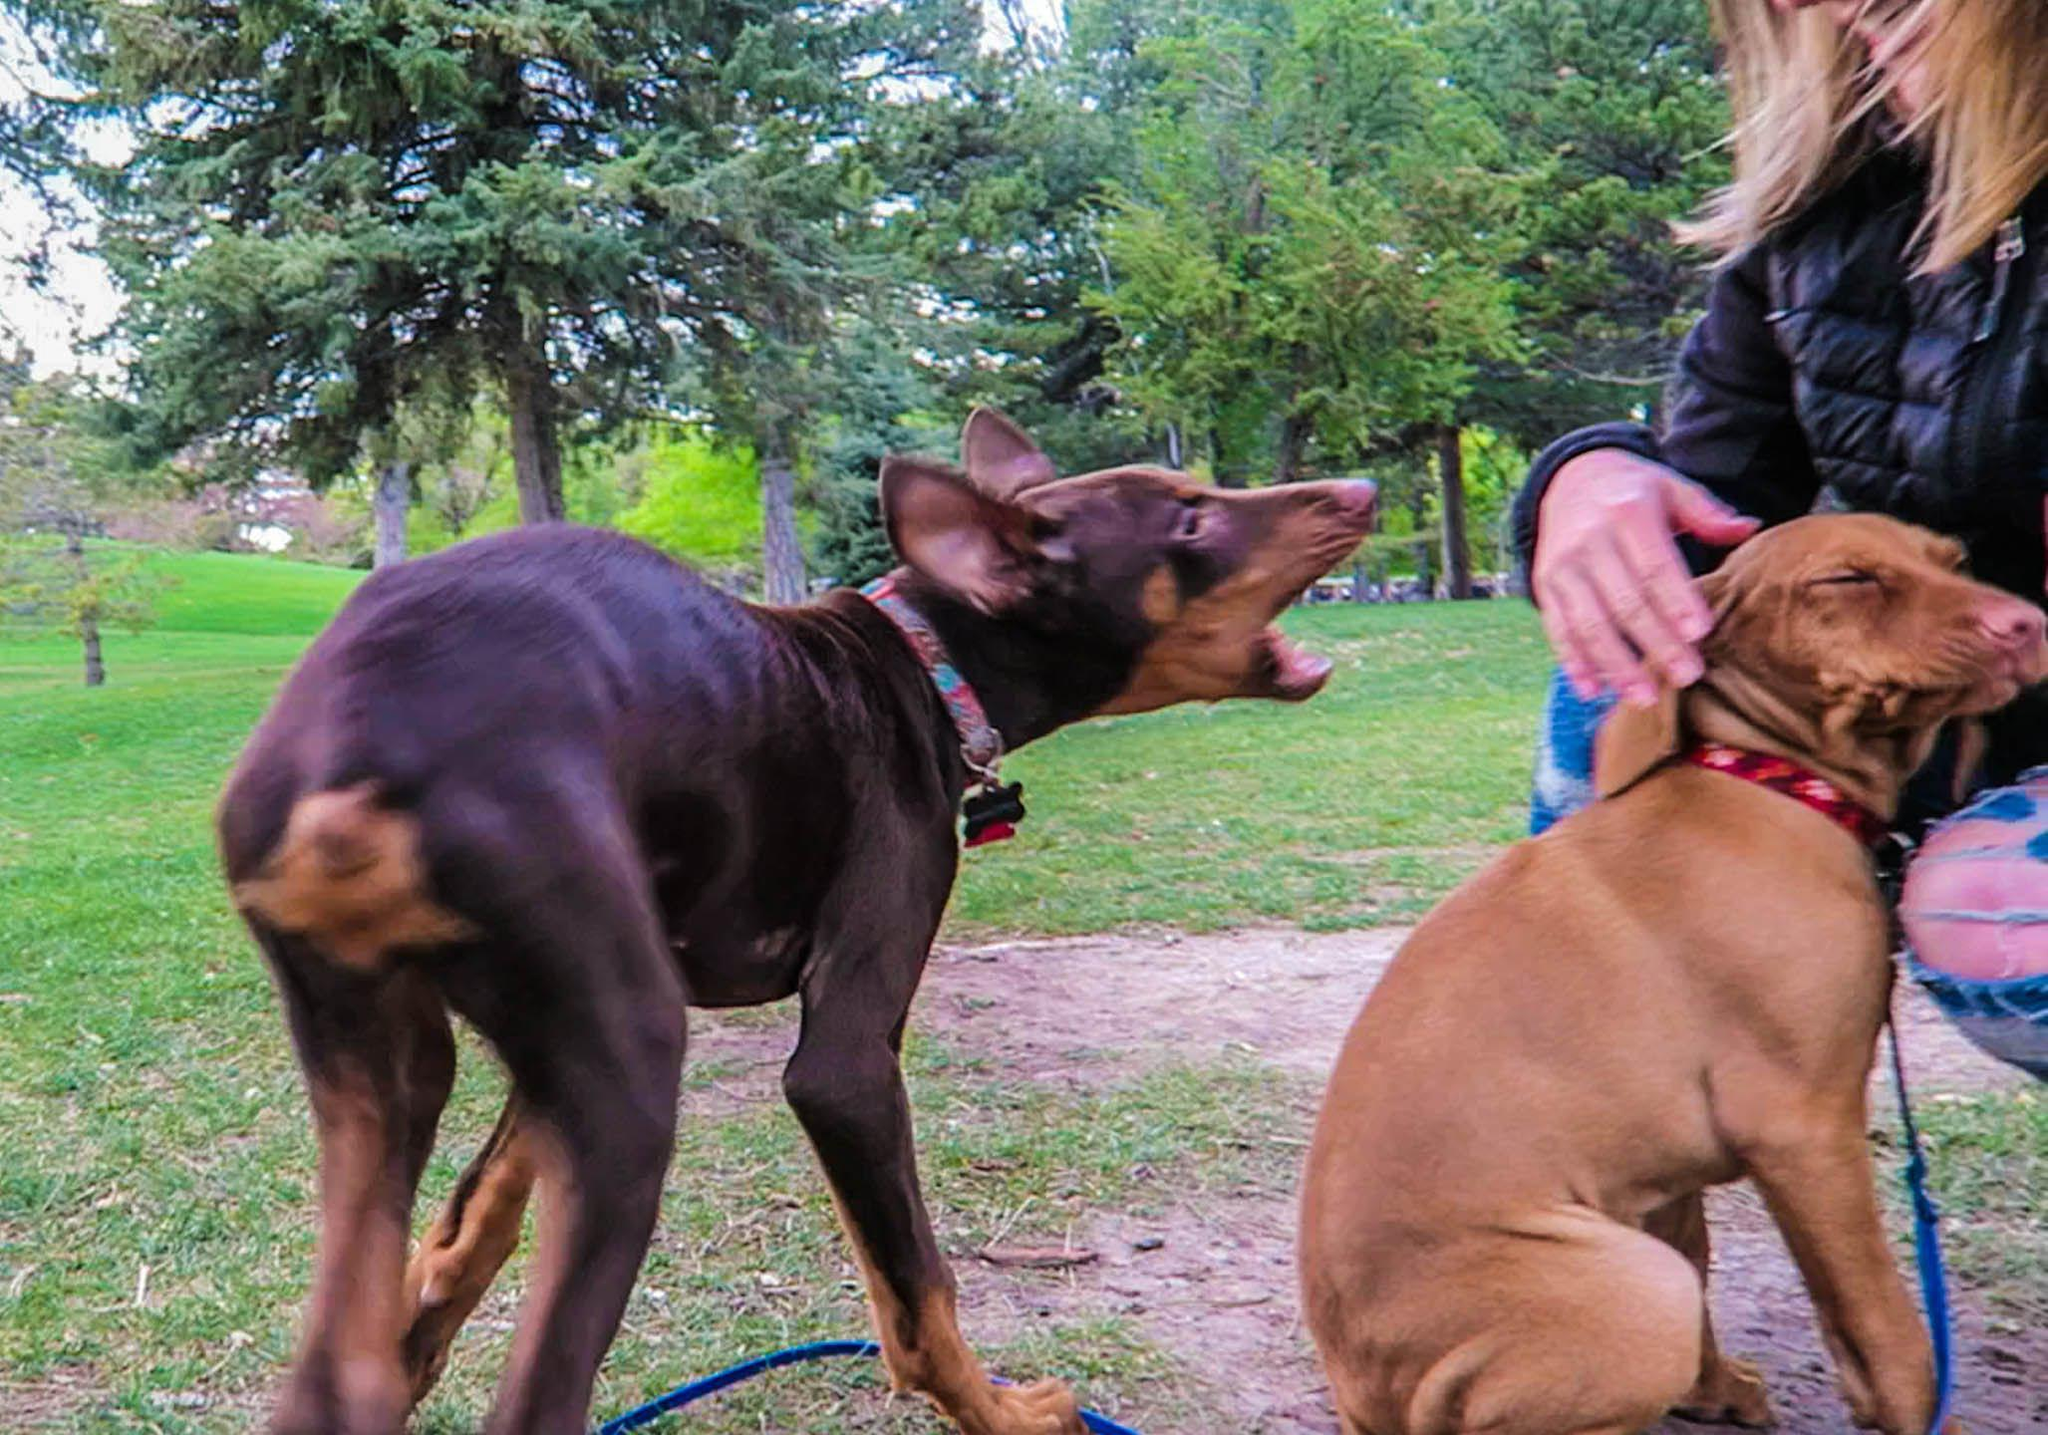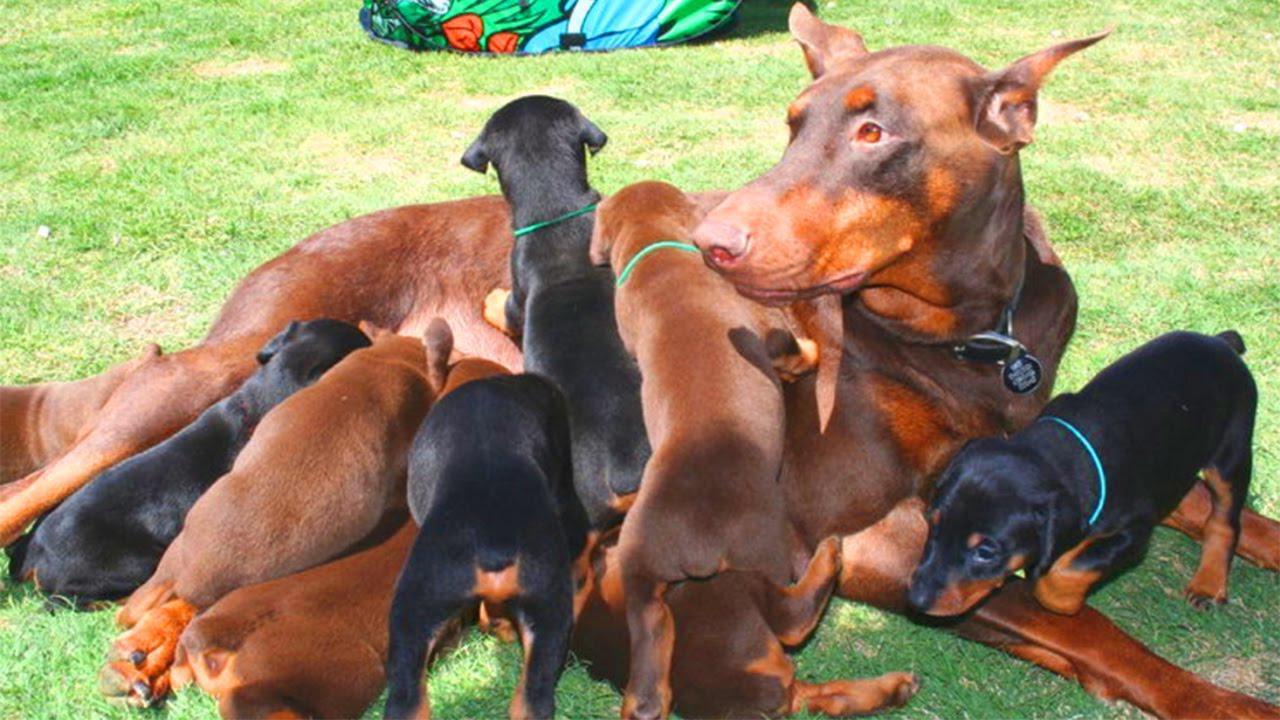The first image is the image on the left, the second image is the image on the right. Examine the images to the left and right. Is the description "In the left image, two dogs are standing side-by-side, with their bodies and heads turned in the same direction." accurate? Answer yes or no. No. The first image is the image on the left, the second image is the image on the right. Evaluate the accuracy of this statement regarding the images: "The right image contains no more than two dogs.". Is it true? Answer yes or no. No. 